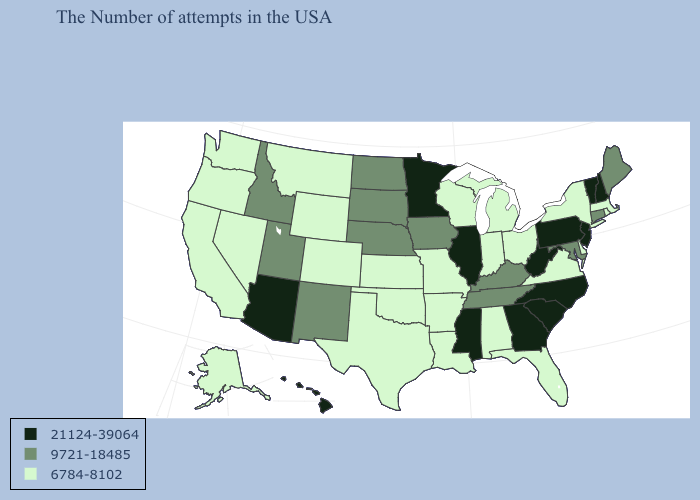Name the states that have a value in the range 6784-8102?
Keep it brief. Massachusetts, Rhode Island, New York, Delaware, Virginia, Ohio, Florida, Michigan, Indiana, Alabama, Wisconsin, Louisiana, Missouri, Arkansas, Kansas, Oklahoma, Texas, Wyoming, Colorado, Montana, Nevada, California, Washington, Oregon, Alaska. Does Montana have the lowest value in the USA?
Be succinct. Yes. Which states hav the highest value in the South?
Keep it brief. North Carolina, South Carolina, West Virginia, Georgia, Mississippi. Does Colorado have a higher value than Florida?
Concise answer only. No. Does Missouri have the lowest value in the MidWest?
Quick response, please. Yes. Name the states that have a value in the range 21124-39064?
Answer briefly. New Hampshire, Vermont, New Jersey, Pennsylvania, North Carolina, South Carolina, West Virginia, Georgia, Illinois, Mississippi, Minnesota, Arizona, Hawaii. Name the states that have a value in the range 9721-18485?
Write a very short answer. Maine, Connecticut, Maryland, Kentucky, Tennessee, Iowa, Nebraska, South Dakota, North Dakota, New Mexico, Utah, Idaho. Name the states that have a value in the range 21124-39064?
Give a very brief answer. New Hampshire, Vermont, New Jersey, Pennsylvania, North Carolina, South Carolina, West Virginia, Georgia, Illinois, Mississippi, Minnesota, Arizona, Hawaii. What is the value of Arkansas?
Give a very brief answer. 6784-8102. Name the states that have a value in the range 6784-8102?
Quick response, please. Massachusetts, Rhode Island, New York, Delaware, Virginia, Ohio, Florida, Michigan, Indiana, Alabama, Wisconsin, Louisiana, Missouri, Arkansas, Kansas, Oklahoma, Texas, Wyoming, Colorado, Montana, Nevada, California, Washington, Oregon, Alaska. Is the legend a continuous bar?
Concise answer only. No. What is the highest value in states that border New Hampshire?
Concise answer only. 21124-39064. What is the value of New Mexico?
Keep it brief. 9721-18485. What is the value of Minnesota?
Write a very short answer. 21124-39064. Name the states that have a value in the range 6784-8102?
Concise answer only. Massachusetts, Rhode Island, New York, Delaware, Virginia, Ohio, Florida, Michigan, Indiana, Alabama, Wisconsin, Louisiana, Missouri, Arkansas, Kansas, Oklahoma, Texas, Wyoming, Colorado, Montana, Nevada, California, Washington, Oregon, Alaska. 